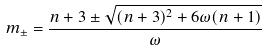<formula> <loc_0><loc_0><loc_500><loc_500>m _ { \pm } = \frac { n + 3 \pm \sqrt { ( n + 3 ) ^ { 2 } + 6 \omega ( n + 1 ) } } { \omega }</formula> 